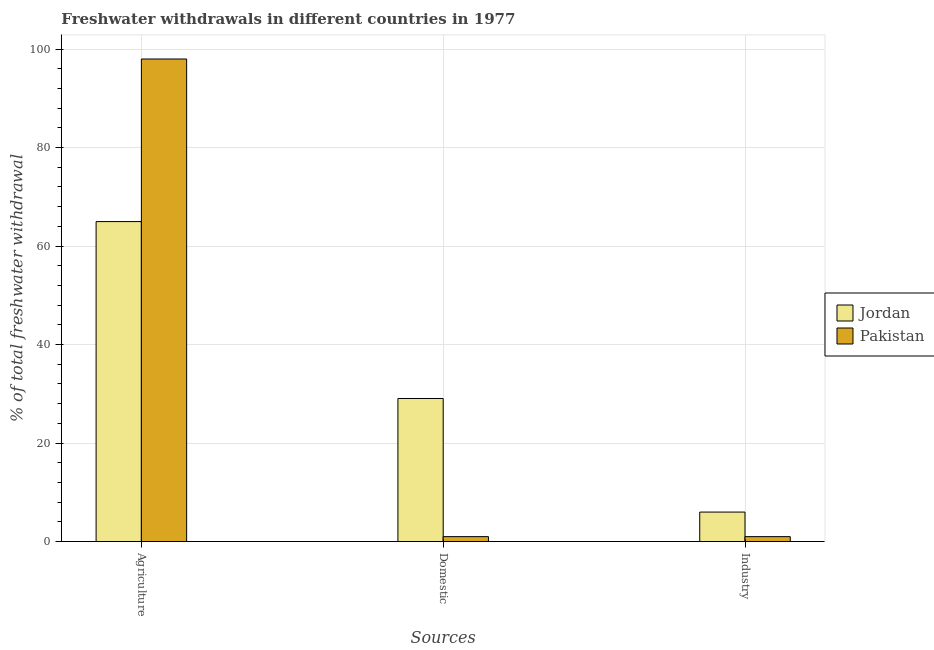Are the number of bars per tick equal to the number of legend labels?
Your response must be concise. Yes. What is the label of the 3rd group of bars from the left?
Your response must be concise. Industry. What is the percentage of freshwater withdrawal for industry in Jordan?
Ensure brevity in your answer.  5.99. Across all countries, what is the maximum percentage of freshwater withdrawal for agriculture?
Offer a terse response. 97.98. Across all countries, what is the minimum percentage of freshwater withdrawal for industry?
Your answer should be compact. 1. In which country was the percentage of freshwater withdrawal for domestic purposes maximum?
Provide a short and direct response. Jordan. What is the total percentage of freshwater withdrawal for domestic purposes in the graph?
Provide a succinct answer. 30.05. What is the difference between the percentage of freshwater withdrawal for industry in Jordan and that in Pakistan?
Provide a short and direct response. 4.99. What is the difference between the percentage of freshwater withdrawal for industry in Pakistan and the percentage of freshwater withdrawal for agriculture in Jordan?
Provide a short and direct response. -63.97. What is the average percentage of freshwater withdrawal for agriculture per country?
Your answer should be compact. 81.47. What is the difference between the percentage of freshwater withdrawal for domestic purposes and percentage of freshwater withdrawal for industry in Jordan?
Provide a short and direct response. 23.06. In how many countries, is the percentage of freshwater withdrawal for domestic purposes greater than 16 %?
Ensure brevity in your answer.  1. What is the ratio of the percentage of freshwater withdrawal for industry in Jordan to that in Pakistan?
Offer a very short reply. 5.99. Is the difference between the percentage of freshwater withdrawal for industry in Jordan and Pakistan greater than the difference between the percentage of freshwater withdrawal for domestic purposes in Jordan and Pakistan?
Provide a short and direct response. No. What is the difference between the highest and the second highest percentage of freshwater withdrawal for domestic purposes?
Offer a terse response. 28.05. What is the difference between the highest and the lowest percentage of freshwater withdrawal for domestic purposes?
Offer a very short reply. 28.05. Is the sum of the percentage of freshwater withdrawal for agriculture in Jordan and Pakistan greater than the maximum percentage of freshwater withdrawal for industry across all countries?
Make the answer very short. Yes. What does the 2nd bar from the left in Industry represents?
Offer a very short reply. Pakistan. What does the 1st bar from the right in Industry represents?
Provide a succinct answer. Pakistan. Are all the bars in the graph horizontal?
Make the answer very short. No. How many countries are there in the graph?
Give a very brief answer. 2. What is the difference between two consecutive major ticks on the Y-axis?
Make the answer very short. 20. Does the graph contain grids?
Ensure brevity in your answer.  Yes. Where does the legend appear in the graph?
Your answer should be very brief. Center right. How many legend labels are there?
Keep it short and to the point. 2. How are the legend labels stacked?
Provide a succinct answer. Vertical. What is the title of the graph?
Provide a succinct answer. Freshwater withdrawals in different countries in 1977. Does "India" appear as one of the legend labels in the graph?
Provide a succinct answer. No. What is the label or title of the X-axis?
Provide a short and direct response. Sources. What is the label or title of the Y-axis?
Make the answer very short. % of total freshwater withdrawal. What is the % of total freshwater withdrawal of Jordan in Agriculture?
Provide a succinct answer. 64.97. What is the % of total freshwater withdrawal in Pakistan in Agriculture?
Give a very brief answer. 97.98. What is the % of total freshwater withdrawal of Jordan in Domestic?
Your answer should be compact. 29.05. What is the % of total freshwater withdrawal of Jordan in Industry?
Keep it short and to the point. 5.99. What is the % of total freshwater withdrawal in Pakistan in Industry?
Ensure brevity in your answer.  1. Across all Sources, what is the maximum % of total freshwater withdrawal of Jordan?
Provide a succinct answer. 64.97. Across all Sources, what is the maximum % of total freshwater withdrawal in Pakistan?
Provide a short and direct response. 97.98. Across all Sources, what is the minimum % of total freshwater withdrawal in Jordan?
Provide a short and direct response. 5.99. Across all Sources, what is the minimum % of total freshwater withdrawal of Pakistan?
Offer a terse response. 1. What is the total % of total freshwater withdrawal in Jordan in the graph?
Your response must be concise. 100.01. What is the total % of total freshwater withdrawal in Pakistan in the graph?
Your answer should be very brief. 99.98. What is the difference between the % of total freshwater withdrawal in Jordan in Agriculture and that in Domestic?
Make the answer very short. 35.92. What is the difference between the % of total freshwater withdrawal in Pakistan in Agriculture and that in Domestic?
Keep it short and to the point. 96.98. What is the difference between the % of total freshwater withdrawal in Jordan in Agriculture and that in Industry?
Offer a terse response. 58.98. What is the difference between the % of total freshwater withdrawal of Pakistan in Agriculture and that in Industry?
Provide a succinct answer. 96.98. What is the difference between the % of total freshwater withdrawal of Jordan in Domestic and that in Industry?
Keep it short and to the point. 23.06. What is the difference between the % of total freshwater withdrawal of Pakistan in Domestic and that in Industry?
Make the answer very short. 0. What is the difference between the % of total freshwater withdrawal of Jordan in Agriculture and the % of total freshwater withdrawal of Pakistan in Domestic?
Give a very brief answer. 63.97. What is the difference between the % of total freshwater withdrawal of Jordan in Agriculture and the % of total freshwater withdrawal of Pakistan in Industry?
Provide a succinct answer. 63.97. What is the difference between the % of total freshwater withdrawal in Jordan in Domestic and the % of total freshwater withdrawal in Pakistan in Industry?
Your answer should be very brief. 28.05. What is the average % of total freshwater withdrawal in Jordan per Sources?
Offer a terse response. 33.34. What is the average % of total freshwater withdrawal in Pakistan per Sources?
Your answer should be very brief. 33.33. What is the difference between the % of total freshwater withdrawal in Jordan and % of total freshwater withdrawal in Pakistan in Agriculture?
Make the answer very short. -33.01. What is the difference between the % of total freshwater withdrawal in Jordan and % of total freshwater withdrawal in Pakistan in Domestic?
Make the answer very short. 28.05. What is the difference between the % of total freshwater withdrawal of Jordan and % of total freshwater withdrawal of Pakistan in Industry?
Offer a terse response. 4.99. What is the ratio of the % of total freshwater withdrawal in Jordan in Agriculture to that in Domestic?
Make the answer very short. 2.24. What is the ratio of the % of total freshwater withdrawal of Pakistan in Agriculture to that in Domestic?
Provide a short and direct response. 97.98. What is the ratio of the % of total freshwater withdrawal in Jordan in Agriculture to that in Industry?
Keep it short and to the point. 10.85. What is the ratio of the % of total freshwater withdrawal of Pakistan in Agriculture to that in Industry?
Your answer should be very brief. 97.98. What is the ratio of the % of total freshwater withdrawal of Jordan in Domestic to that in Industry?
Give a very brief answer. 4.85. What is the difference between the highest and the second highest % of total freshwater withdrawal of Jordan?
Make the answer very short. 35.92. What is the difference between the highest and the second highest % of total freshwater withdrawal in Pakistan?
Keep it short and to the point. 96.98. What is the difference between the highest and the lowest % of total freshwater withdrawal of Jordan?
Your answer should be compact. 58.98. What is the difference between the highest and the lowest % of total freshwater withdrawal in Pakistan?
Offer a terse response. 96.98. 